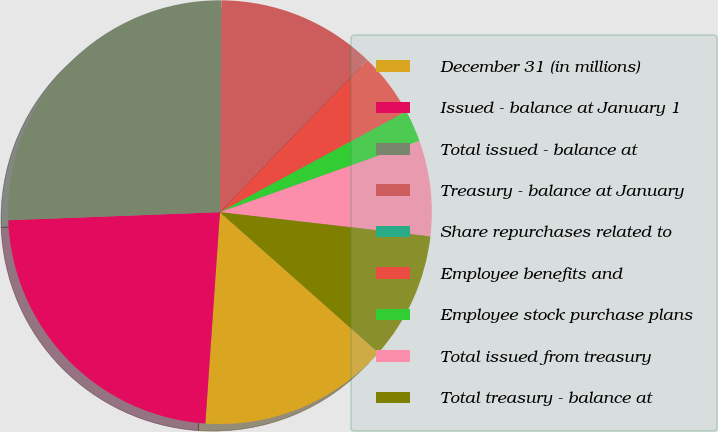<chart> <loc_0><loc_0><loc_500><loc_500><pie_chart><fcel>December 31 (in millions)<fcel>Issued - balance at January 1<fcel>Total issued - balance at<fcel>Treasury - balance at January<fcel>Share repurchases related to<fcel>Employee benefits and<fcel>Employee stock purchase plans<fcel>Total issued from treasury<fcel>Total treasury - balance at<nl><fcel>14.56%<fcel>23.3%<fcel>25.72%<fcel>12.13%<fcel>0.01%<fcel>4.86%<fcel>2.43%<fcel>7.28%<fcel>9.71%<nl></chart> 